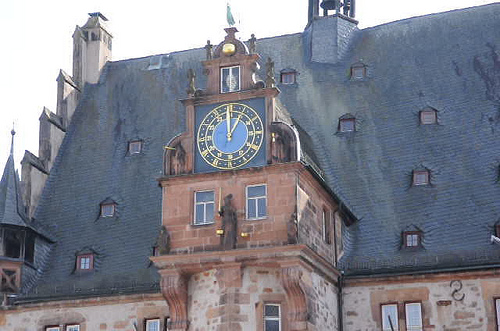How many lightning rods are visible? Upon reviewing the image, one lightning rod can be seen protruding from the apex of the roof structure, likely intended to protect the building from lightning strikes by safely channeling the electrical charge to the ground. 